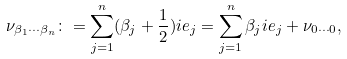Convert formula to latex. <formula><loc_0><loc_0><loc_500><loc_500>\nu _ { \beta _ { 1 } \cdots \beta _ { n } } \colon = \sum _ { j = 1 } ^ { n } ( \beta _ { j } + \frac { 1 } { 2 } ) i e _ { j } = \sum _ { j = 1 } ^ { n } \beta _ { j } i e _ { j } + \nu _ { 0 \cdots 0 } ,</formula> 